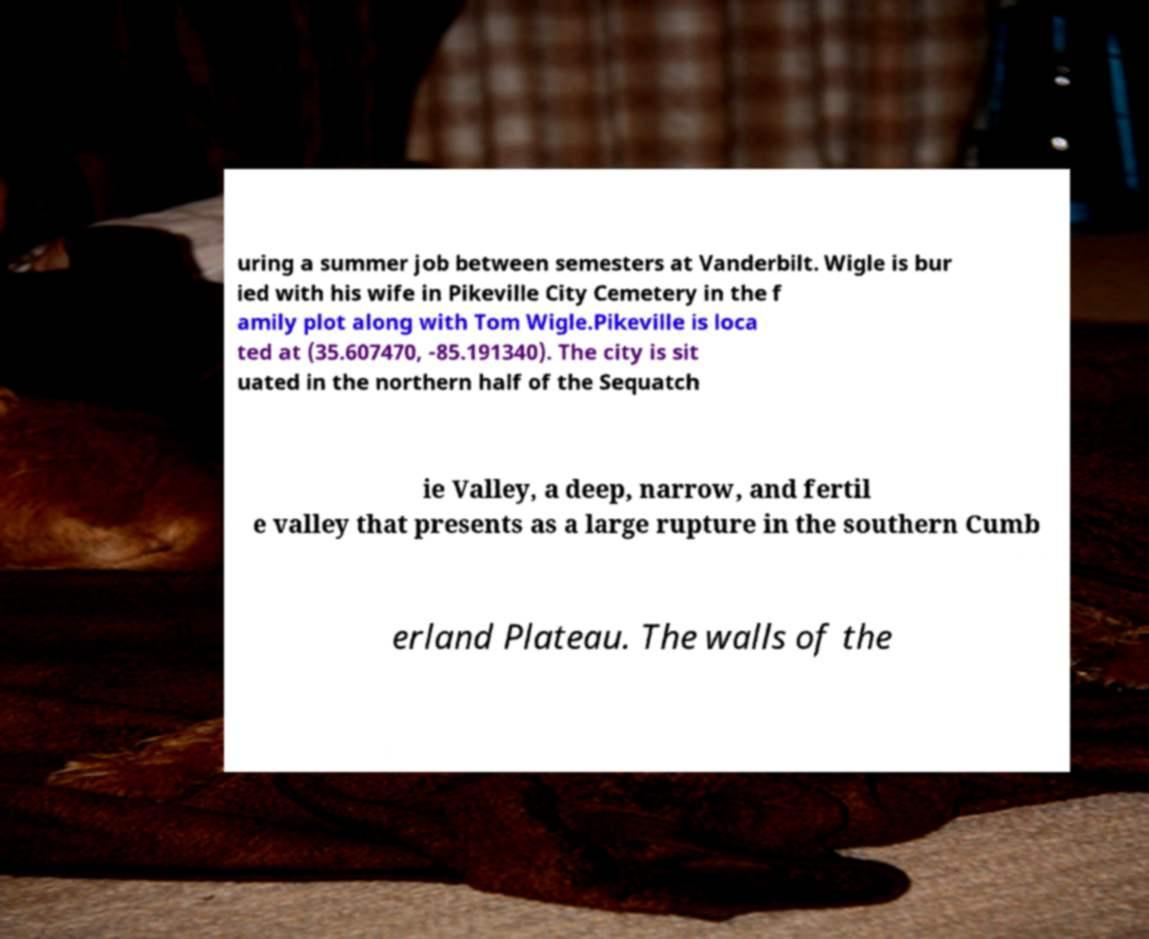Please identify and transcribe the text found in this image. uring a summer job between semesters at Vanderbilt. Wigle is bur ied with his wife in Pikeville City Cemetery in the f amily plot along with Tom Wigle.Pikeville is loca ted at (35.607470, -85.191340). The city is sit uated in the northern half of the Sequatch ie Valley, a deep, narrow, and fertil e valley that presents as a large rupture in the southern Cumb erland Plateau. The walls of the 